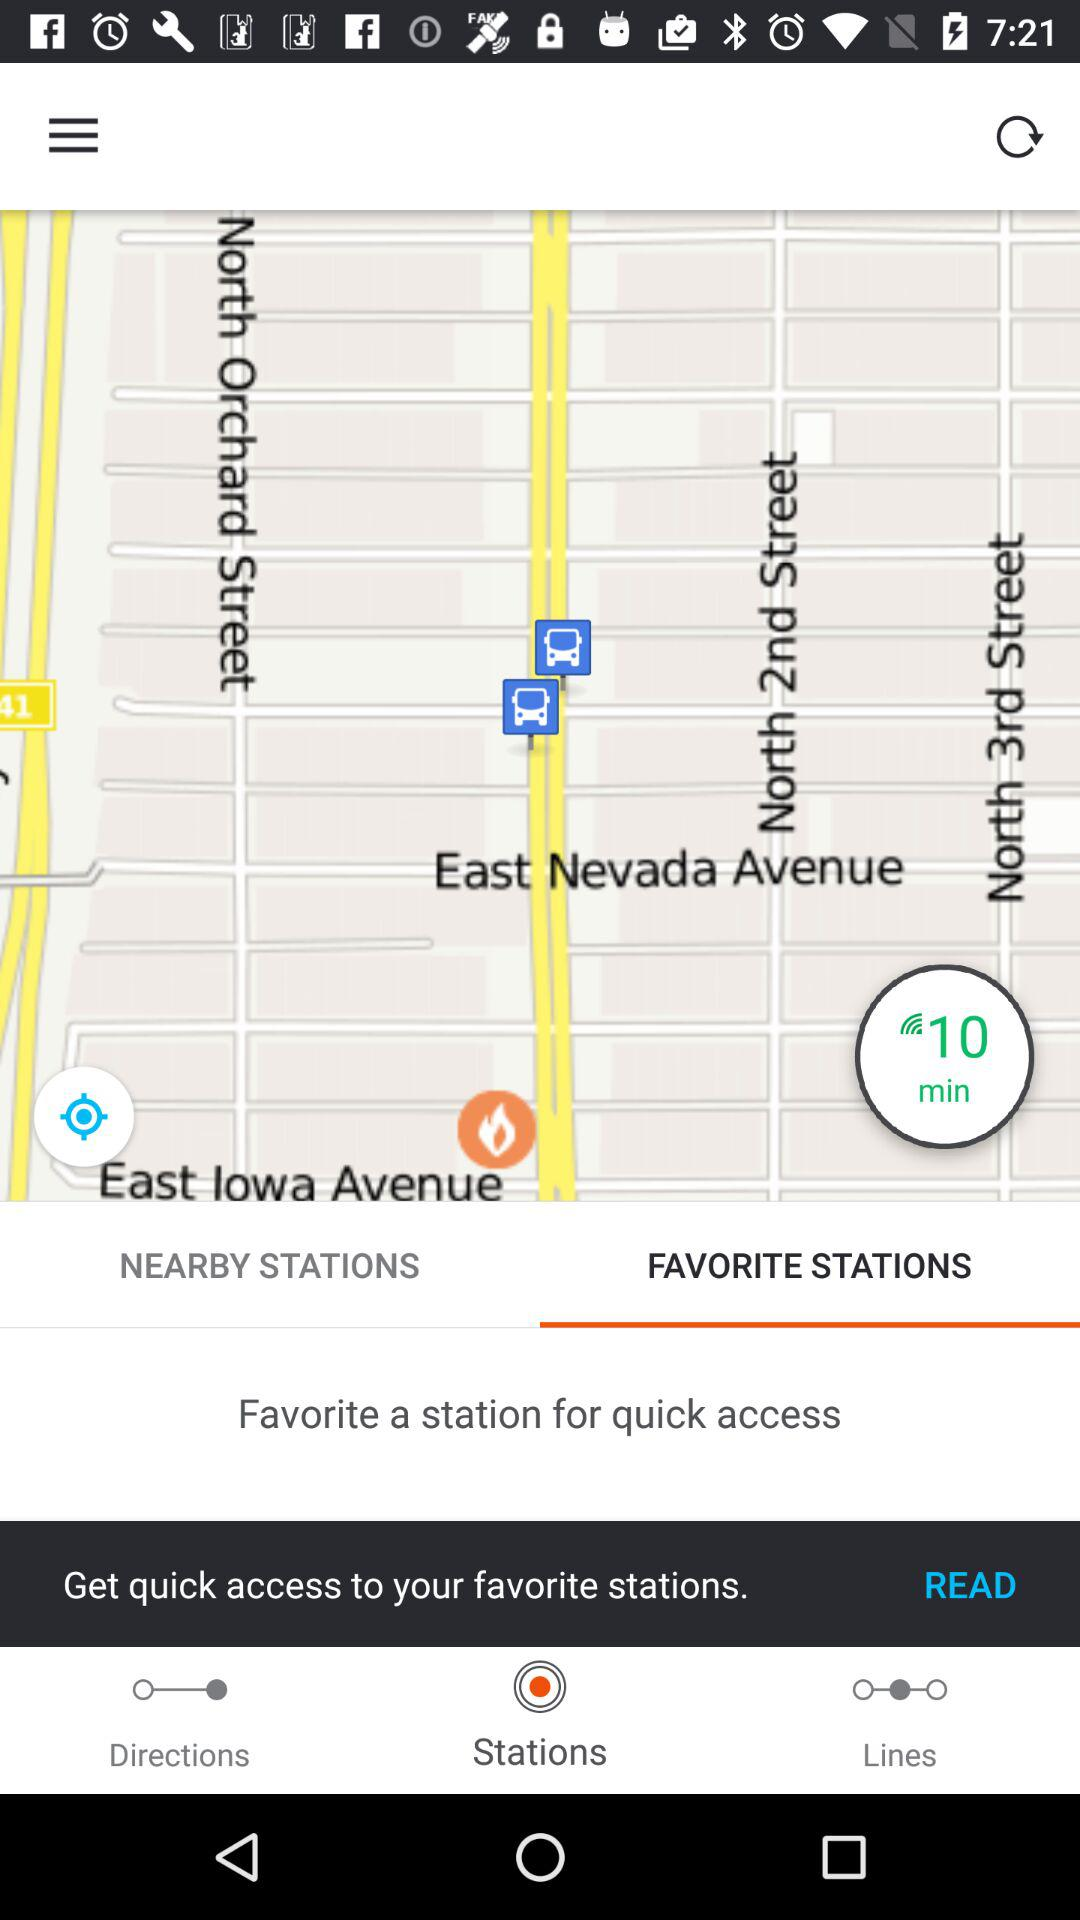What is the selected tab? The selected tab is Favorite Stations. 